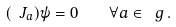Convert formula to latex. <formula><loc_0><loc_0><loc_500><loc_500>( \ J _ { a } ) \psi = 0 \quad \forall a \in \ g \, .</formula> 